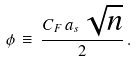<formula> <loc_0><loc_0><loc_500><loc_500>\phi \, \equiv \, \frac { C _ { F } \, a _ { s } \, \sqrt { n } } { 2 } \, .</formula> 